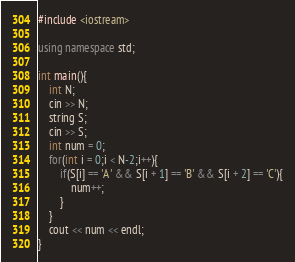<code> <loc_0><loc_0><loc_500><loc_500><_C++_>
#include <iostream>

using namespace std;

int main(){
    int N;
    cin >> N;
    string S;
    cin >> S;
    int num = 0;
    for(int i = 0;i < N-2;i++){
        if(S[i] == 'A' && S[i + 1] == 'B' && S[i + 2] == 'C'){
            num++;
        }
    }
    cout << num << endl;
}</code> 